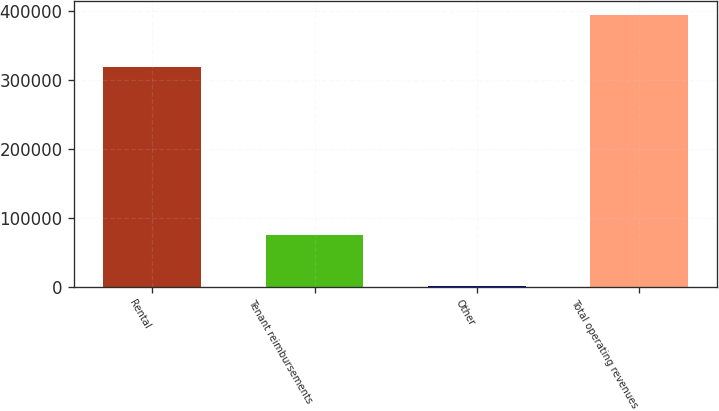Convert chart to OTSL. <chart><loc_0><loc_0><loc_500><loc_500><bar_chart><fcel>Rental<fcel>Tenant reimbursements<fcel>Other<fcel>Total operating revenues<nl><fcel>319603<fcel>75003<fcel>641<fcel>395247<nl></chart> 